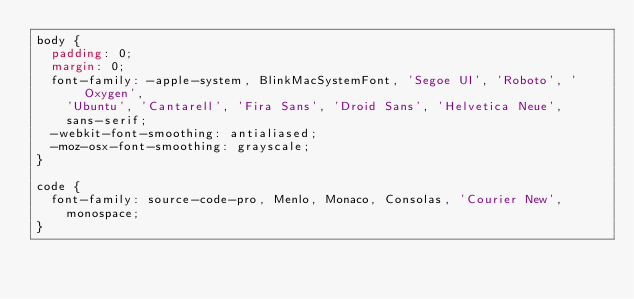Convert code to text. <code><loc_0><loc_0><loc_500><loc_500><_CSS_>body {
	padding: 0;
	margin: 0;
	font-family: -apple-system, BlinkMacSystemFont, 'Segoe UI', 'Roboto', 'Oxygen',
		'Ubuntu', 'Cantarell', 'Fira Sans', 'Droid Sans', 'Helvetica Neue',
		sans-serif;
	-webkit-font-smoothing: antialiased;
	-moz-osx-font-smoothing: grayscale;
}

code {
	font-family: source-code-pro, Menlo, Monaco, Consolas, 'Courier New',
		monospace;
}
</code> 